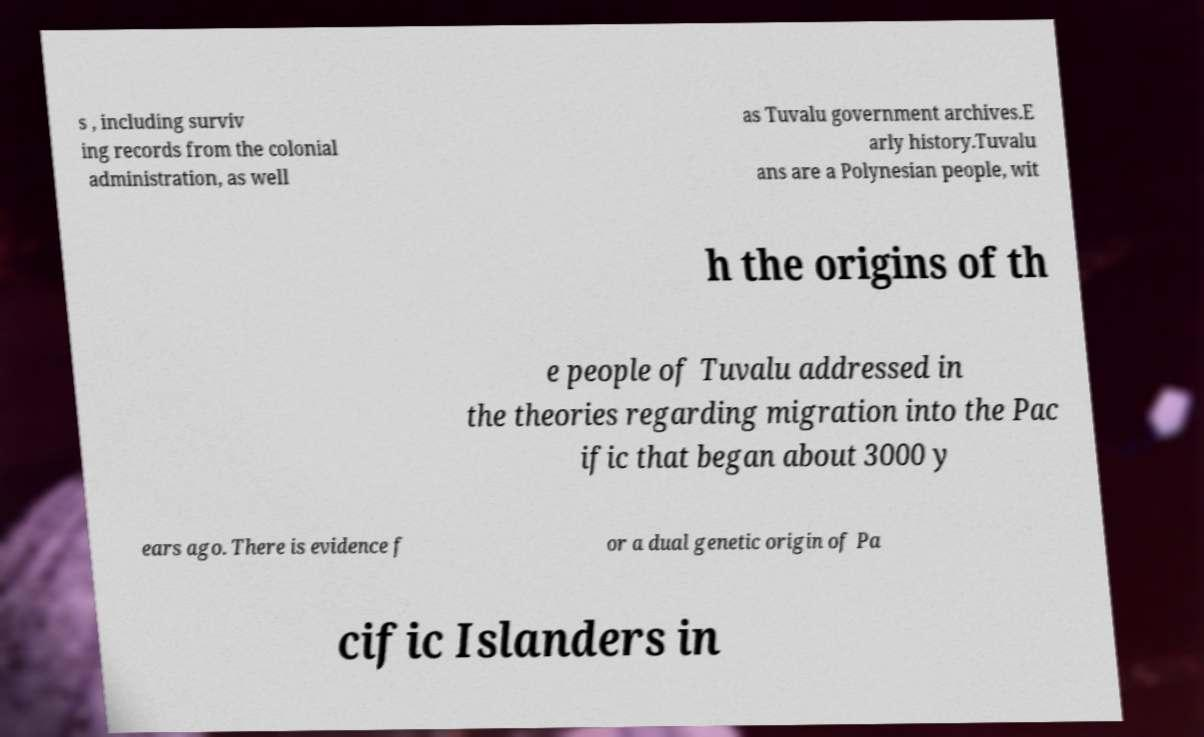Could you extract and type out the text from this image? s , including surviv ing records from the colonial administration, as well as Tuvalu government archives.E arly history.Tuvalu ans are a Polynesian people, wit h the origins of th e people of Tuvalu addressed in the theories regarding migration into the Pac ific that began about 3000 y ears ago. There is evidence f or a dual genetic origin of Pa cific Islanders in 